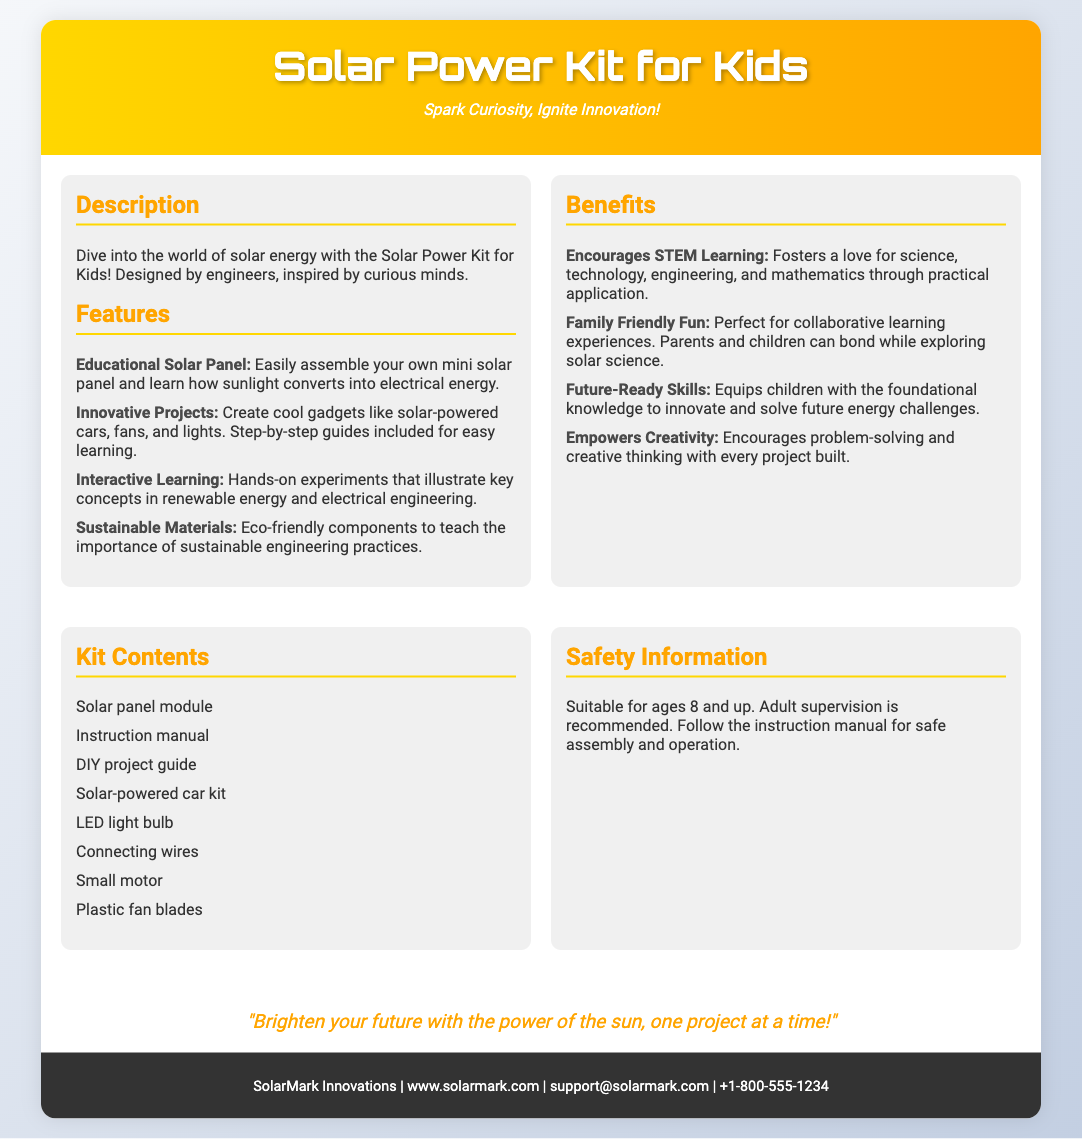What is the title of the product? The title of the product is provided in the document header.
Answer: Solar Power Kit for Kids What age group is the kit suitable for? The safety information section specifies the recommended age for use.
Answer: Ages 8 and up What is one of the innovative projects mentioned? The features section lists various projects that can be created with the kit.
Answer: Solar-powered cars How many items are included in the kit? The kit contents section enumerates the items included in the package.
Answer: Eight items What does the tagline suggest? The tagline provides insight into the purpose and aim of the product.
Answer: Spark Curiosity, Ignite Innovation! What material quality is emphasized in the kit features? The features specifically mention a key aspect of the components used in the kit.
Answer: Eco-friendly components Which organization created this Solar Power Kit? The footer provides the name of the company responsible for the product.
Answer: SolarMark Innovations What skill does the kit aim to foster? The benefits section highlights a key educational focus of the kit.
Answer: STEM Learning 